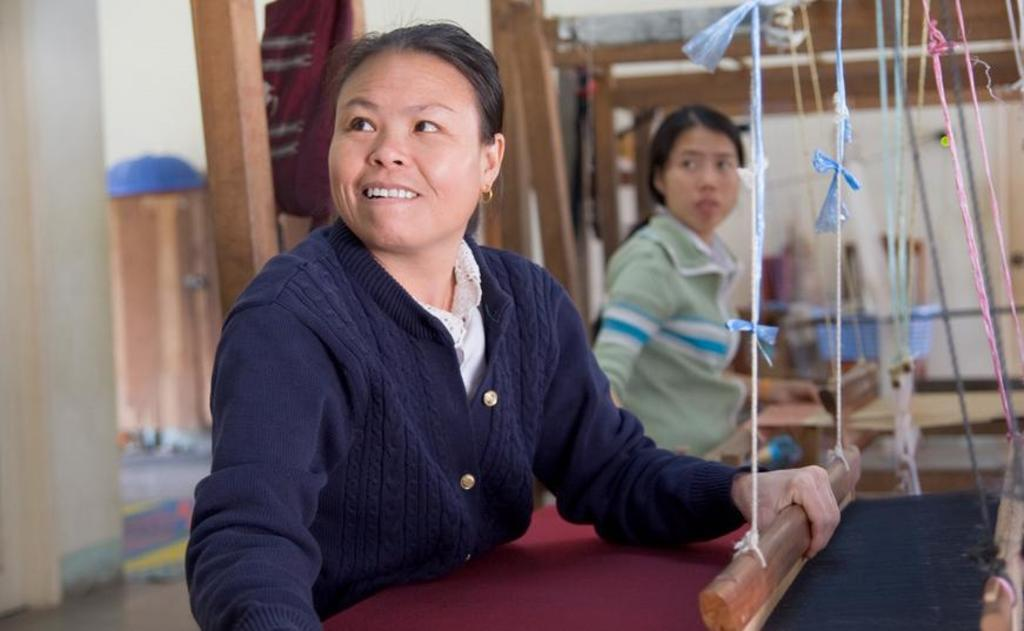Who is the main subject in the image? There is a woman in the image. What is the woman doing in the image? The woman is loom weaving. Are there any other people present in the image? Yes, there is another person in the image. What can be seen in the background of the image? There are objects visible in the background of the image. What type of amusement can be seen in the image? There is no amusement present in the image; it features a woman loom weaving and another person. Is there a door visible in the image? There is no door visible in the image; it focuses on the woman loom weaving and the objects in the background. 